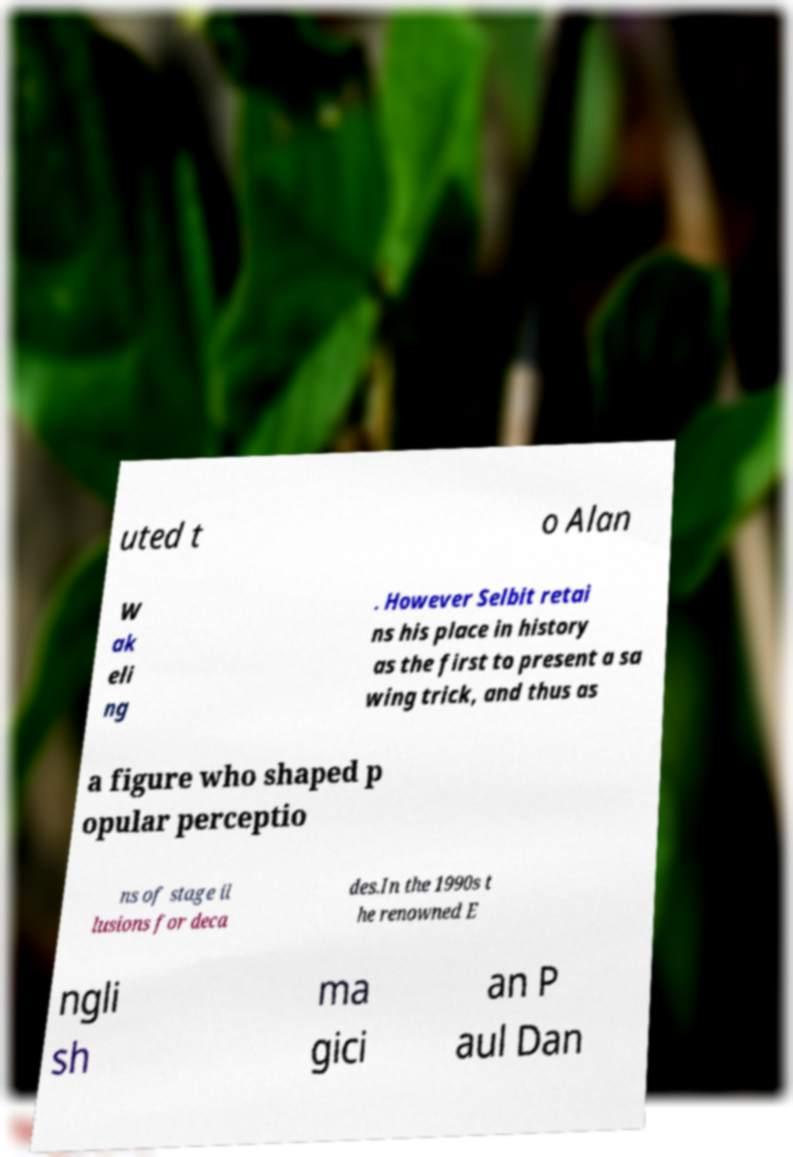Could you extract and type out the text from this image? uted t o Alan W ak eli ng . However Selbit retai ns his place in history as the first to present a sa wing trick, and thus as a figure who shaped p opular perceptio ns of stage il lusions for deca des.In the 1990s t he renowned E ngli sh ma gici an P aul Dan 